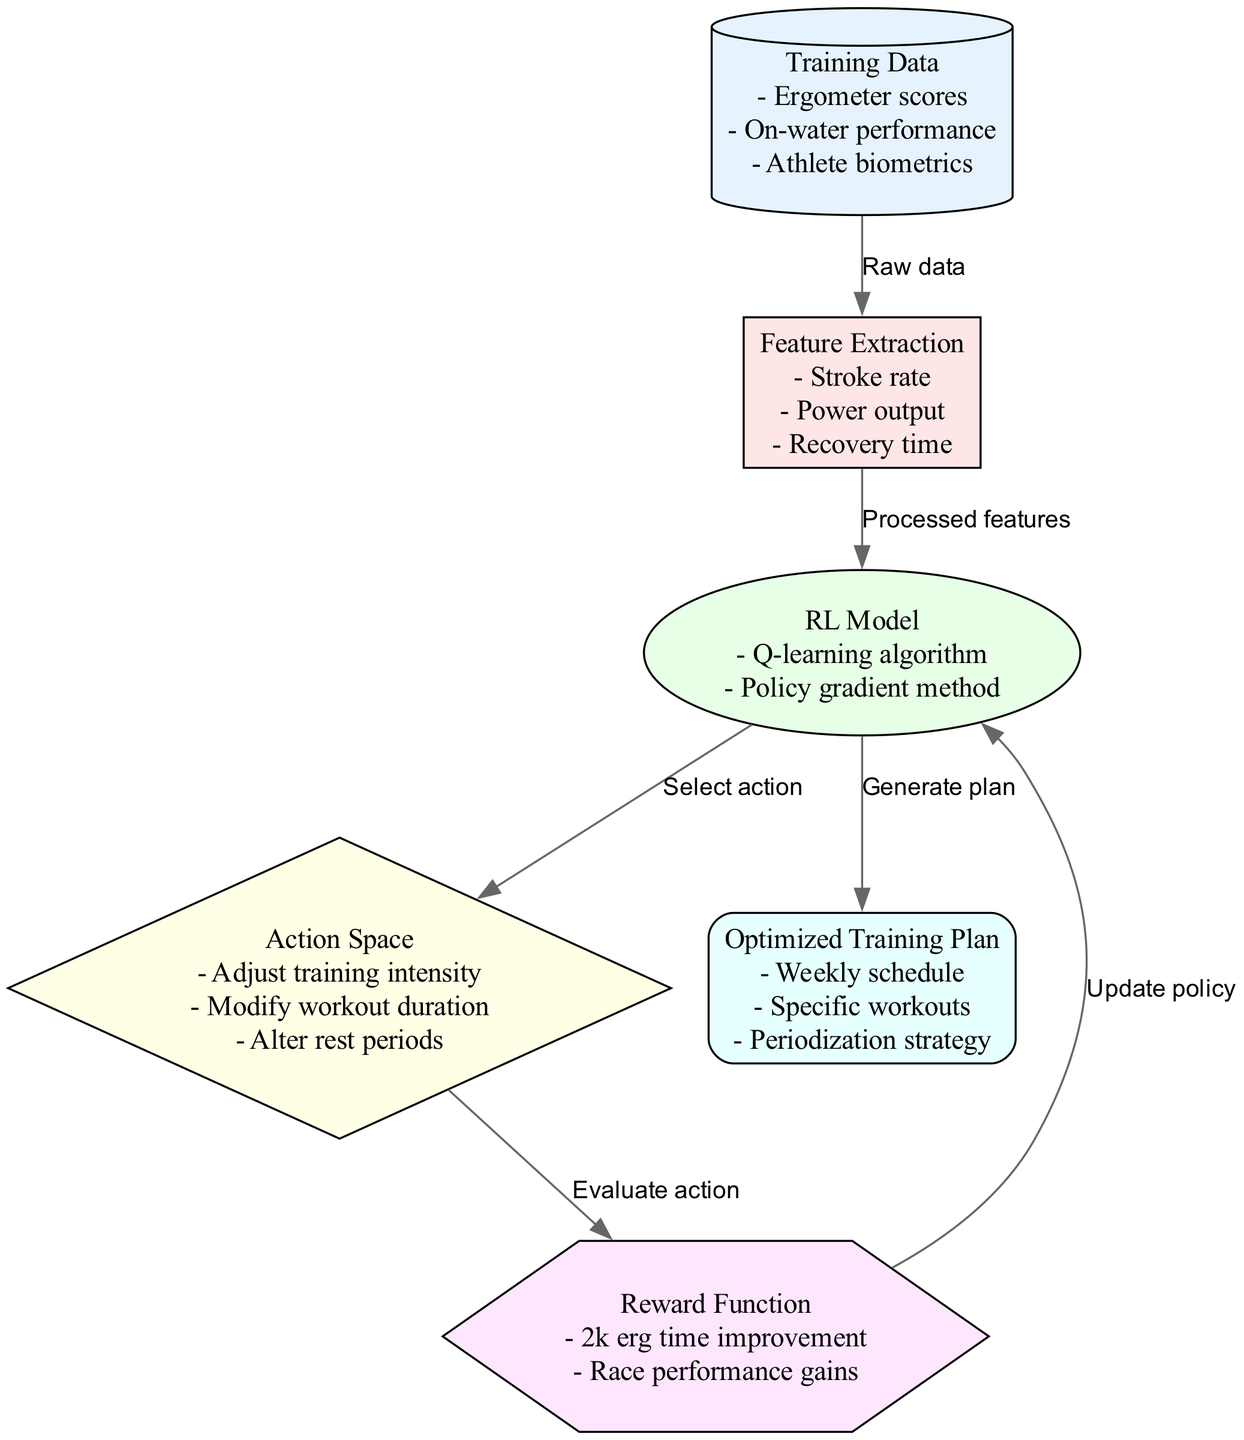What are the inputs used in the model? The diagram shows that the inputs to the model are "Training Data" which includes "Ergometer scores", "On-water performance", and "Athlete biometrics".
Answer: Training Data - Ergometer scores - On-water performance - Athlete biometrics How many nodes are in the diagram? By counting the nodes in the diagram, we see there are six nodes: input_data, feature_extraction, rl_model, action_space, reward_function, and output.
Answer: 6 What is the action space in the model? The action space is defined in the diagram as "Adjust training intensity", "Modify workout duration", and "Alter rest periods".
Answer: Adjust training intensity - Modify workout duration - Alter rest periods What does the reward function evaluate? The reward function evaluates the effectiveness of actions taken by the model. According to the diagram, it evaluates based on "2k erg time improvement" and "Race performance gains".
Answer: 2k erg time improvement - Race performance gains What does the RL model generate? The RL model generates an "Optimized Training Plan", which consists of the "Weekly schedule", "Specific workouts", and "Periodization strategy".
Answer: Optimized Training Plan - Weekly schedule - Specific workouts - Periodization strategy How does feature extraction relate to the input data? The edge from input_data to feature_extraction indicates that feature extraction takes "Raw data" from the training data, processing it into features like stroke rate, power output, and recovery time.
Answer: Raw data What action is selected by the RL model? According to the diagram, the RL model selects actions from the action space, which include adjusting training intensity, modifying workout duration, and altering rest periods.
Answer: Select action How does the reward function impact the RL model? The diagram indicates that the reward function provides feedback to the RL model after evaluating actions, leading to policy updates which refine future actions.
Answer: Update policy 